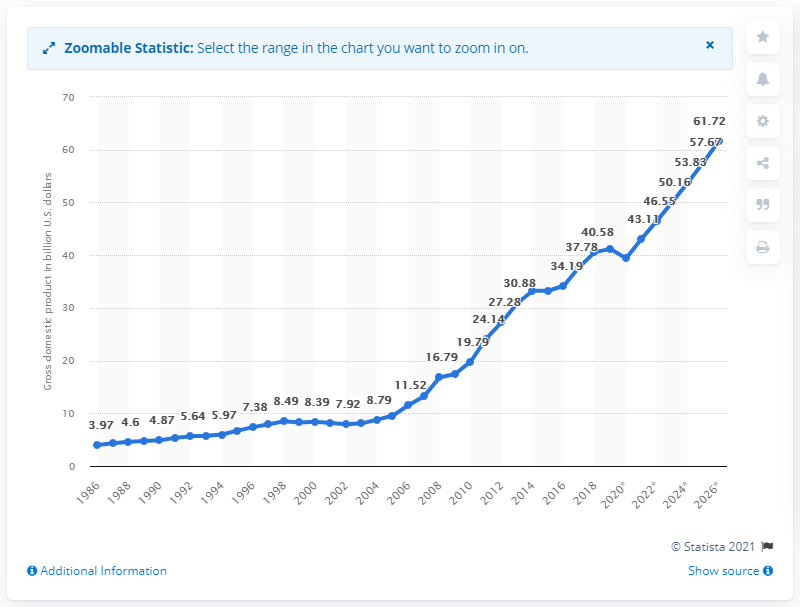Draw attention to some important aspects in this diagram. In 2019, the gross domestic product of Bolivia was 41.19. 